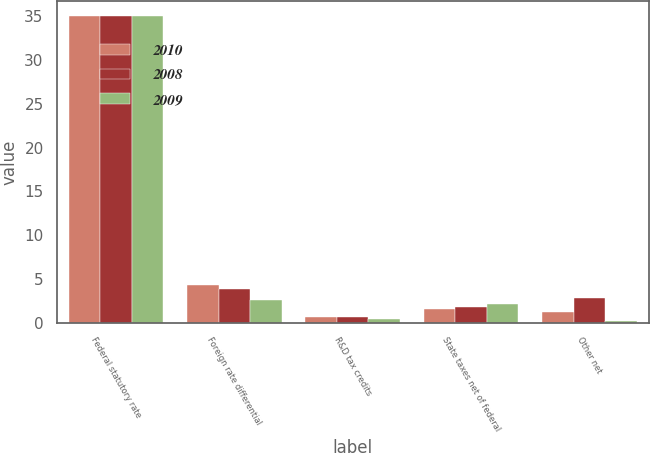Convert chart. <chart><loc_0><loc_0><loc_500><loc_500><stacked_bar_chart><ecel><fcel>Federal statutory rate<fcel>Foreign rate differential<fcel>R&D tax credits<fcel>State taxes net of federal<fcel>Other net<nl><fcel>2010<fcel>35<fcel>4.3<fcel>0.6<fcel>1.6<fcel>1.2<nl><fcel>2008<fcel>35<fcel>3.9<fcel>0.6<fcel>1.8<fcel>2.8<nl><fcel>2009<fcel>35<fcel>2.6<fcel>0.4<fcel>2.1<fcel>0.2<nl></chart> 